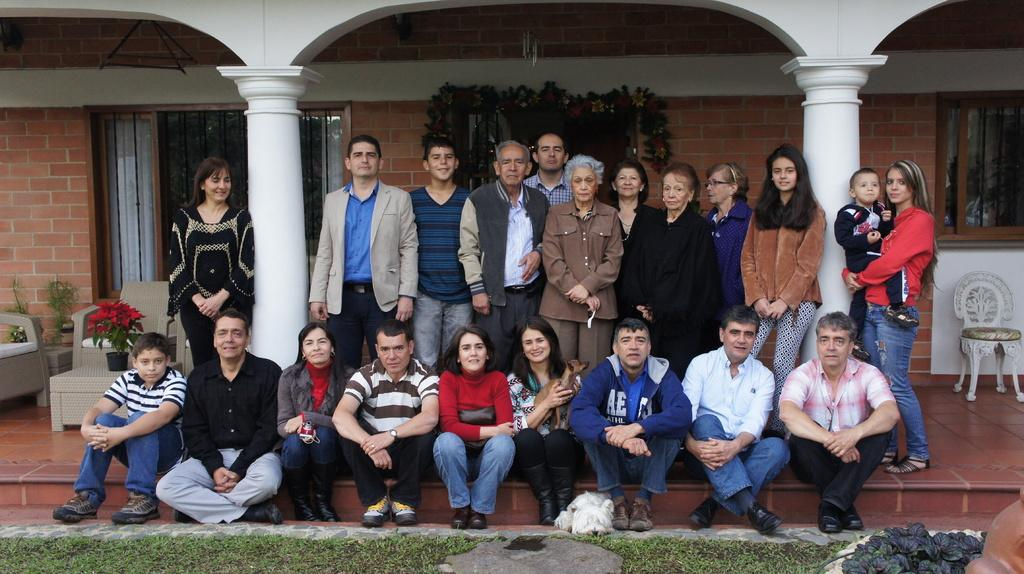What is the main subject in the center of the image? There are people in the center of the image. What type of terrain is visible at the bottom side of the image? There is grassland at the bottom side of the image. Where are the chairs located in the image? There are chairs on both the right and left sides of the image. What type of shop can be seen in the background of the image? There is no shop visible in the image; it primarily features people, grassland, and chairs. What is the comparison between the breakfast options in the image? There is no breakfast or any food items mentioned in the image, so it is not possible to make a comparison. 